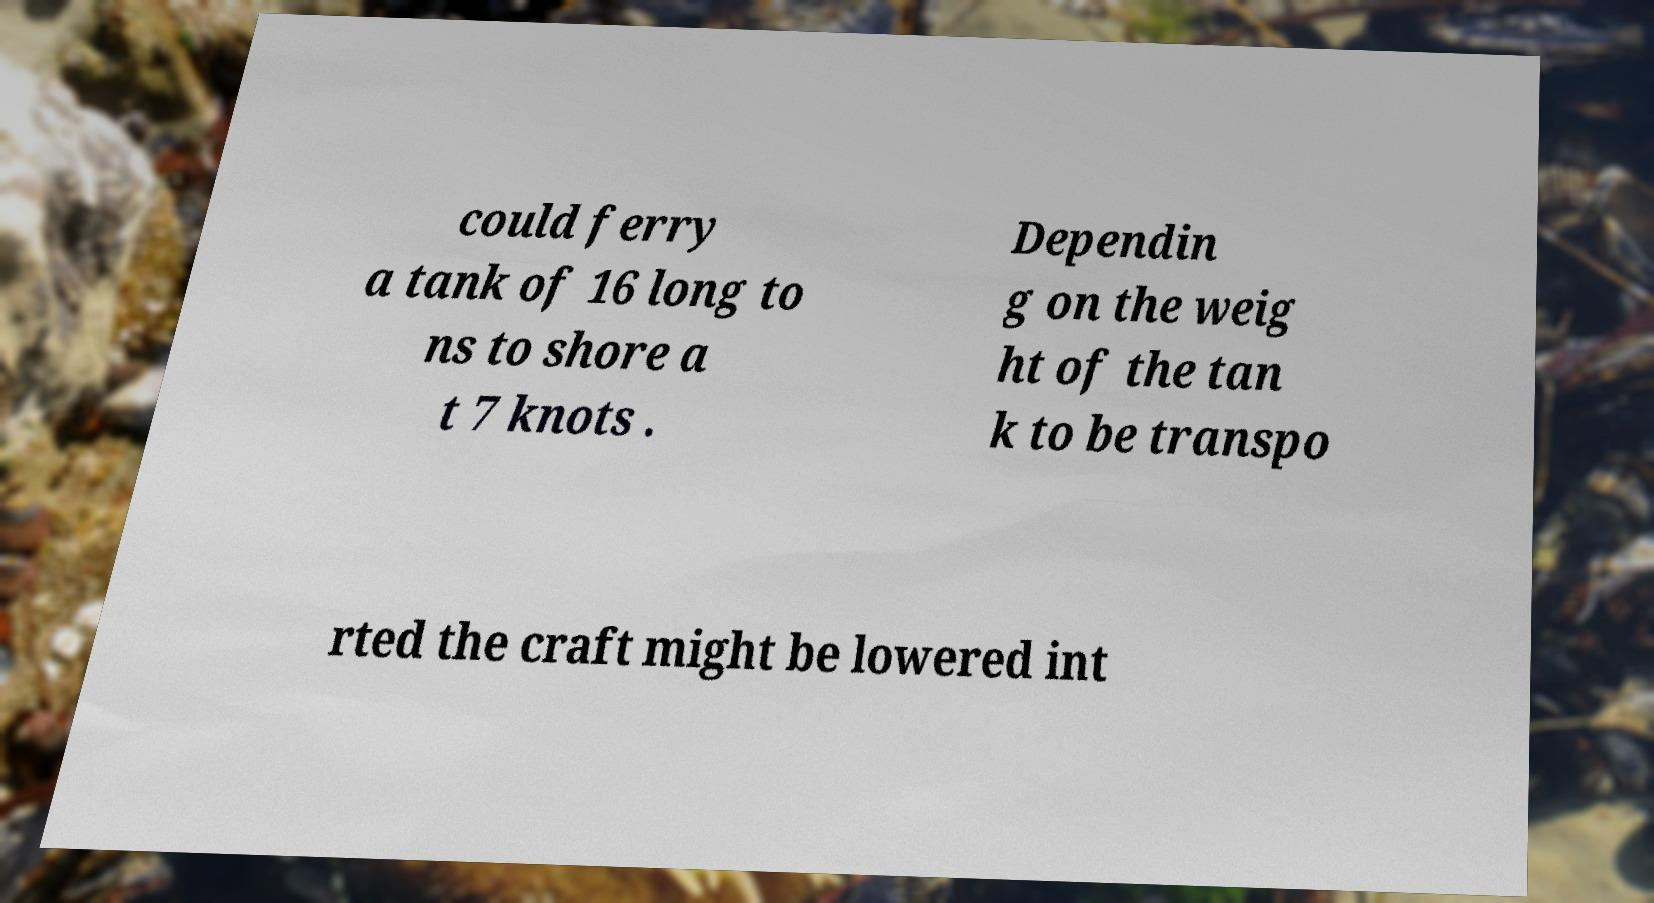Could you assist in decoding the text presented in this image and type it out clearly? could ferry a tank of 16 long to ns to shore a t 7 knots . Dependin g on the weig ht of the tan k to be transpo rted the craft might be lowered int 